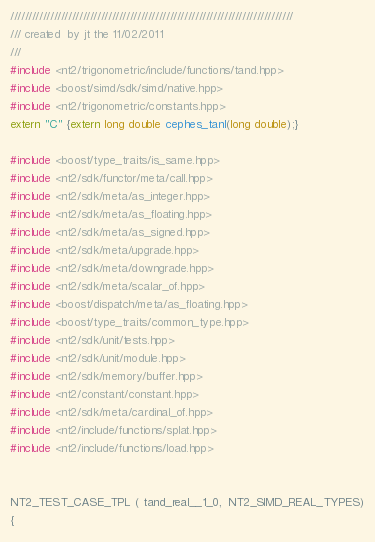Convert code to text. <code><loc_0><loc_0><loc_500><loc_500><_C++_>//////////////////////////////////////////////////////////////////////////////
/// created  by jt the 11/02/2011
///
#include <nt2/trigonometric/include/functions/tand.hpp>
#include <boost/simd/sdk/simd/native.hpp>
#include <nt2/trigonometric/constants.hpp>
extern "C" {extern long double cephes_tanl(long double);}

#include <boost/type_traits/is_same.hpp>
#include <nt2/sdk/functor/meta/call.hpp>
#include <nt2/sdk/meta/as_integer.hpp>
#include <nt2/sdk/meta/as_floating.hpp>
#include <nt2/sdk/meta/as_signed.hpp>
#include <nt2/sdk/meta/upgrade.hpp>
#include <nt2/sdk/meta/downgrade.hpp>
#include <nt2/sdk/meta/scalar_of.hpp>
#include <boost/dispatch/meta/as_floating.hpp>
#include <boost/type_traits/common_type.hpp>
#include <nt2/sdk/unit/tests.hpp>
#include <nt2/sdk/unit/module.hpp>
#include <nt2/sdk/memory/buffer.hpp>
#include <nt2/constant/constant.hpp>
#include <nt2/sdk/meta/cardinal_of.hpp>
#include <nt2/include/functions/splat.hpp>
#include <nt2/include/functions/load.hpp>


NT2_TEST_CASE_TPL ( tand_real__1_0,  NT2_SIMD_REAL_TYPES)
{</code> 